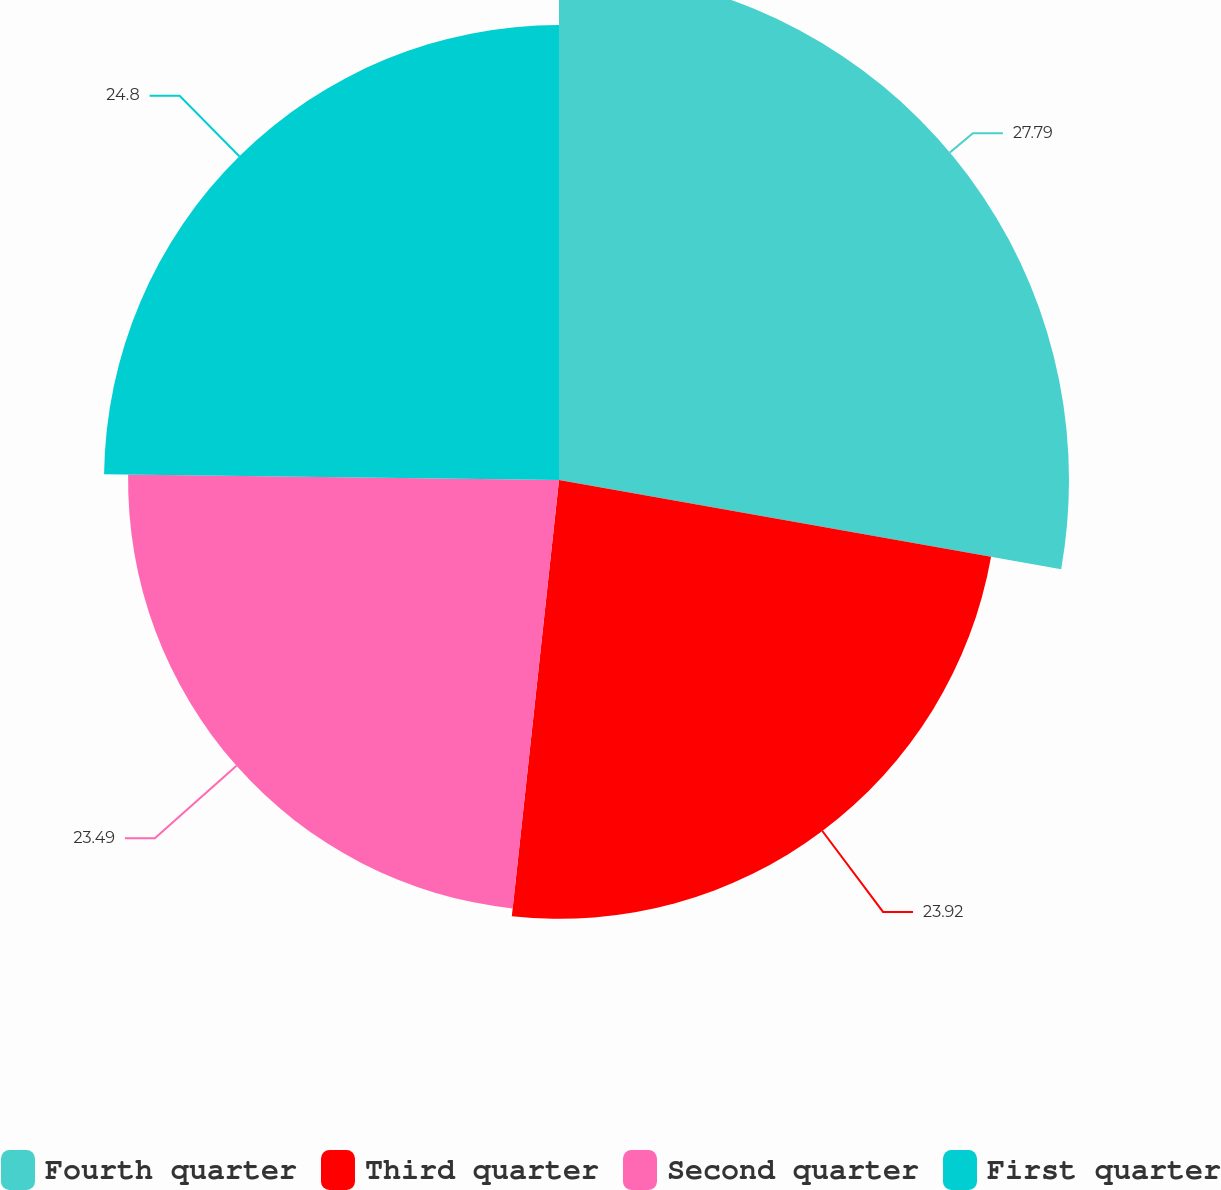<chart> <loc_0><loc_0><loc_500><loc_500><pie_chart><fcel>Fourth quarter<fcel>Third quarter<fcel>Second quarter<fcel>First quarter<nl><fcel>27.8%<fcel>23.92%<fcel>23.49%<fcel>24.8%<nl></chart> 